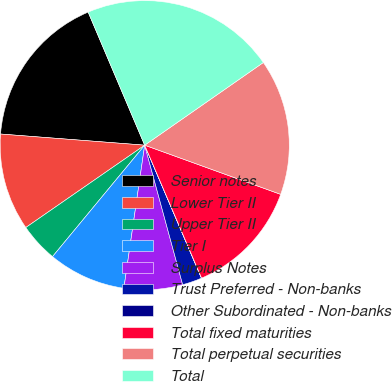Convert chart. <chart><loc_0><loc_0><loc_500><loc_500><pie_chart><fcel>Senior notes<fcel>Lower Tier II<fcel>Upper Tier II<fcel>Tier I<fcel>Surplus Notes<fcel>Trust Preferred - Non-banks<fcel>Other Subordinated - Non-banks<fcel>Total fixed maturities<fcel>Total perpetual securities<fcel>Total<nl><fcel>17.38%<fcel>10.87%<fcel>4.36%<fcel>8.7%<fcel>6.53%<fcel>2.19%<fcel>0.02%<fcel>13.04%<fcel>15.21%<fcel>21.71%<nl></chart> 